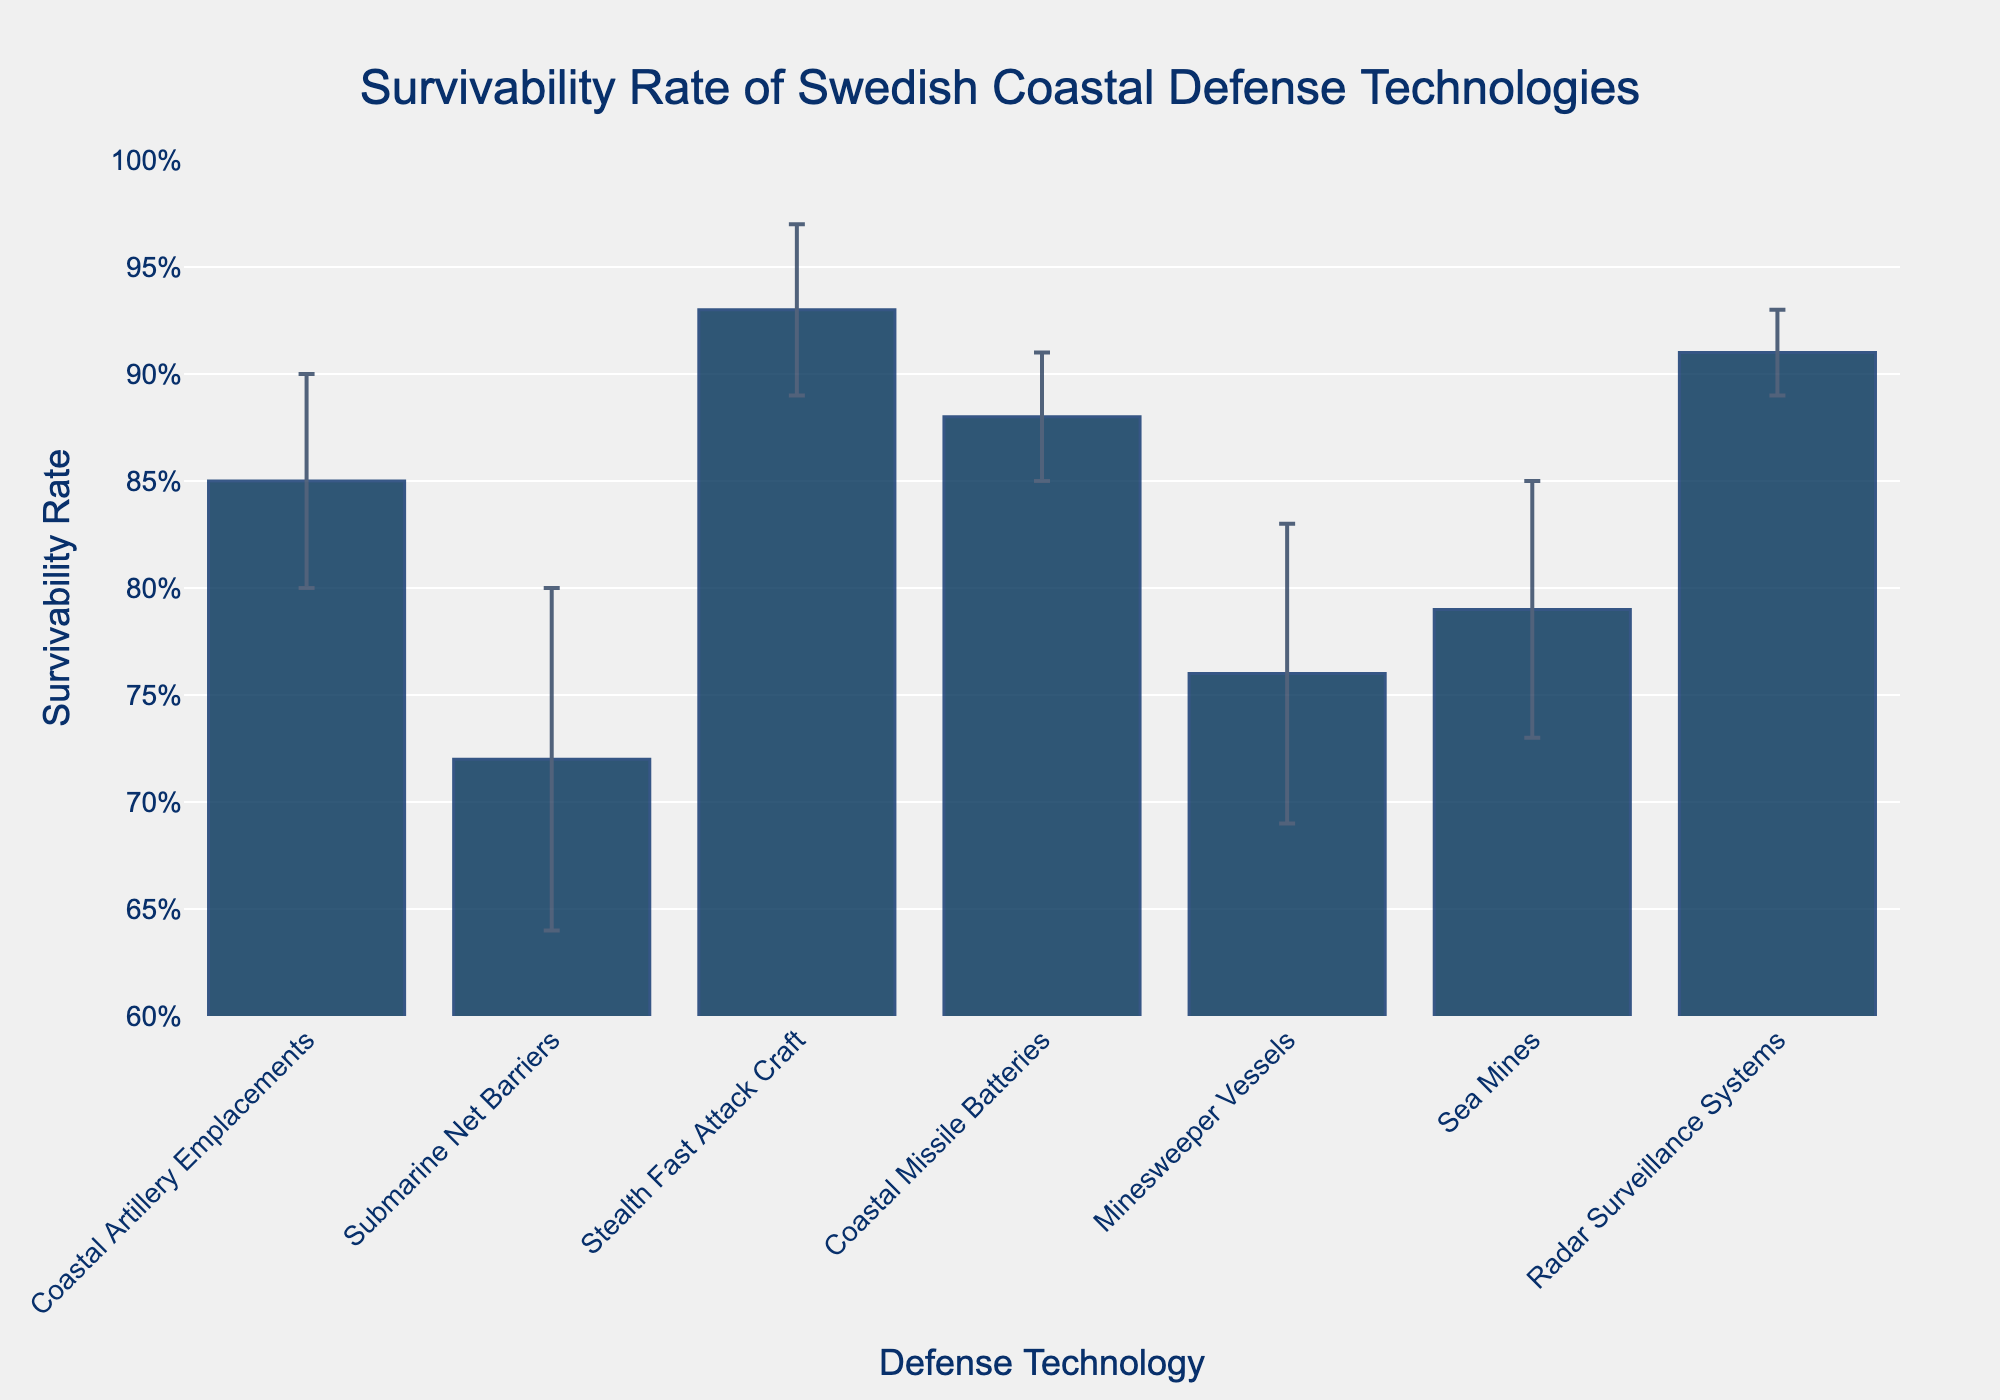What is the technology with the highest survivability rate? The figure shows that the Stealth Fast Attack Craft has the highest bar among all the technologies.
Answer: Stealth Fast Attack Craft What is the title of the figure? The title is located at the top of the figure. It reads "Survivability Rate of Swedish Coastal Defense Technologies".
Answer: Survivability Rate of Swedish Coastal Defense Technologies How does the survivability rate of Coastal Missile Batteries compare to that of Sea Mines? The height of the bar for Coastal Missile Batteries (0.88) is higher than that of Sea Mines (0.79).
Answer: Coastal Missile Batteries have a higher survivability rate What are the error margins for Radar Surveillance Systems and Minesweeper Vessels? The error margins are represented by the length of the vertical lines on top of the bars. For Radar Surveillance Systems, it is 0.02, and for Minesweeper Vessels, it is 0.07.
Answer: 0.02 for Radar Surveillance Systems, 0.07 for Minesweeper Vessels Which technology has the smallest error margin? By observing the length of the error bars, Radar Surveillance Systems has the smallest error margin of 0.02.
Answer: Radar Surveillance Systems What is the difference in survivability rate between Coastal Artillery Emplacements and Submarine Net Barriers? Coastal Artillery Emplacements have a survivability rate of 0.85, while Submarine Net Barriers have 0.72. The difference is 0.85 - 0.72 = 0.13.
Answer: 0.13 How many technologies have a survivability rate above 0.8? The figure shows bars and values of the survivability rates. Stealth Fast Attack Craft (0.93), Coastal Missile Batteries (0.88), Radar Surveillance Systems (0.91), and Coastal Artillery Emplacements (0.85) are above 0.8. There are 4 such technologies.
Answer: 4 What is the average survivability rate for all the technologies shown? Add up all the survivability rates: 0.85 + 0.72 + 0.93 + 0.88 + 0.76 + 0.79 + 0.91 = 5.84. Divide by the number of technologies (7): 5.84 / 7 ≈ 0.834.
Answer: 0.834 Which technology has the highest risk of failure based on the error margins? Compare the error margins provided. Submarine Net Barriers have the highest error margin of 0.08, indicating the highest uncertainty in survivability.
Answer: Submarine Net Barriers 